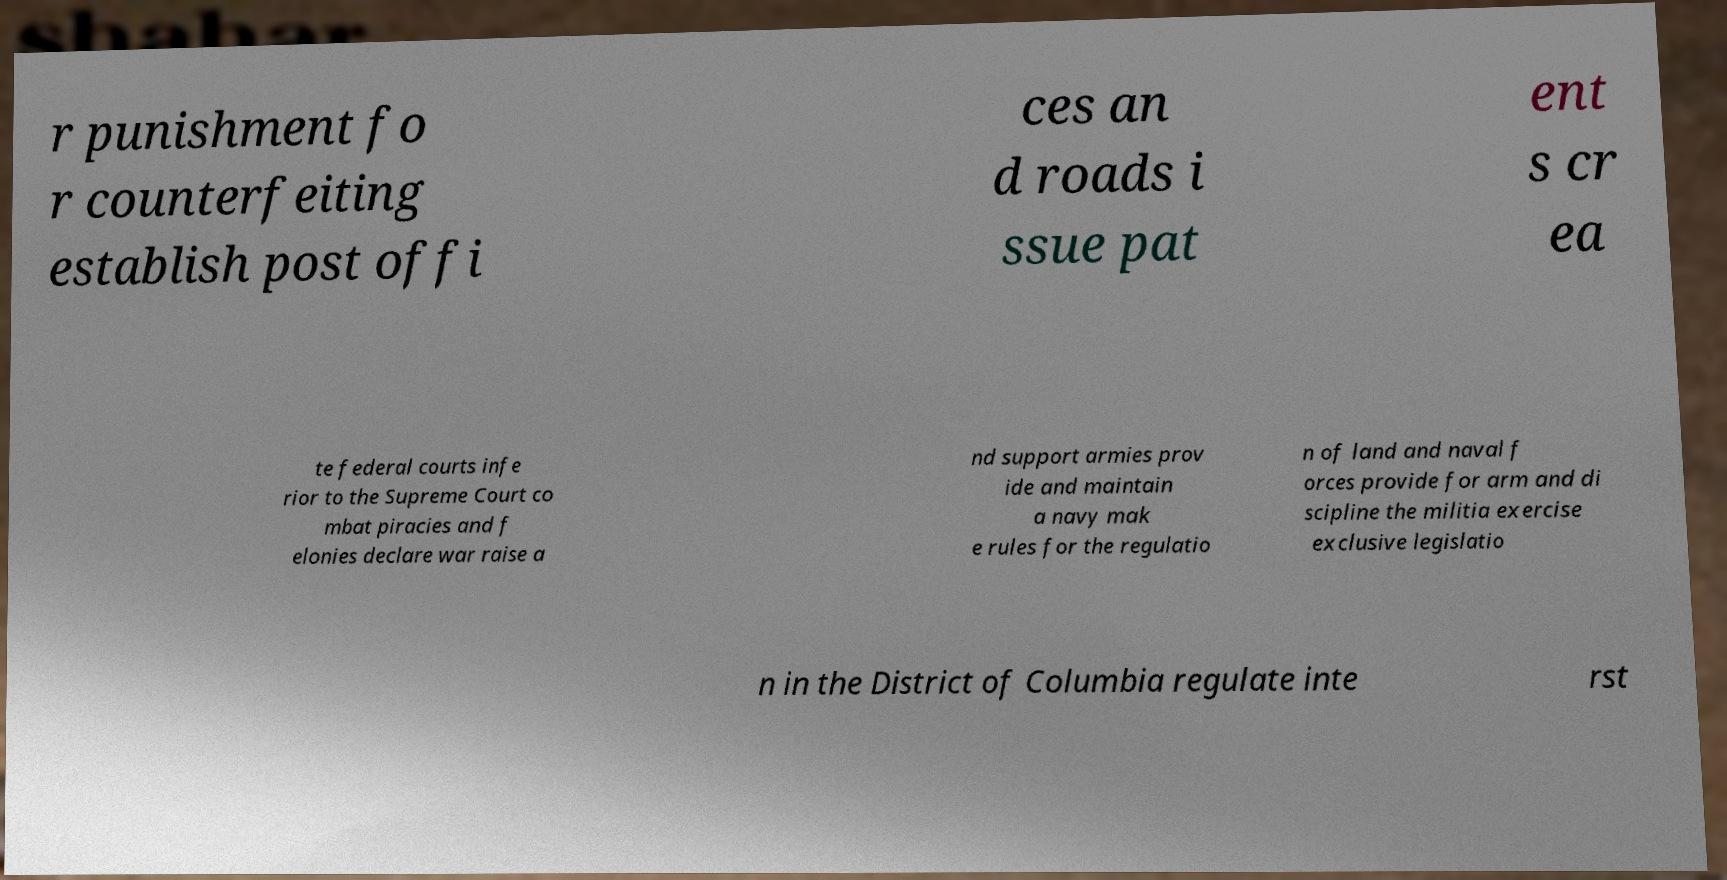There's text embedded in this image that I need extracted. Can you transcribe it verbatim? r punishment fo r counterfeiting establish post offi ces an d roads i ssue pat ent s cr ea te federal courts infe rior to the Supreme Court co mbat piracies and f elonies declare war raise a nd support armies prov ide and maintain a navy mak e rules for the regulatio n of land and naval f orces provide for arm and di scipline the militia exercise exclusive legislatio n in the District of Columbia regulate inte rst 